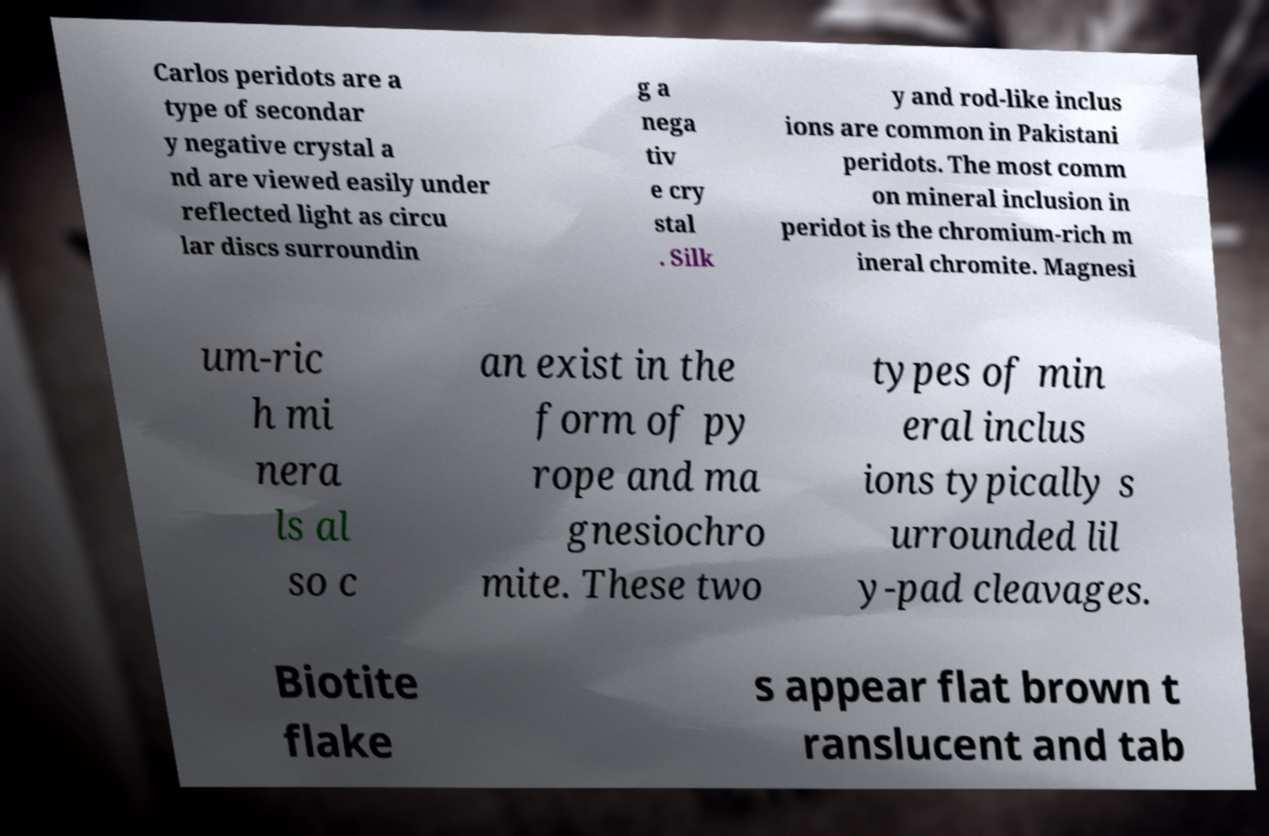Please identify and transcribe the text found in this image. Carlos peridots are a type of secondar y negative crystal a nd are viewed easily under reflected light as circu lar discs surroundin g a nega tiv e cry stal . Silk y and rod-like inclus ions are common in Pakistani peridots. The most comm on mineral inclusion in peridot is the chromium-rich m ineral chromite. Magnesi um-ric h mi nera ls al so c an exist in the form of py rope and ma gnesiochro mite. These two types of min eral inclus ions typically s urrounded lil y-pad cleavages. Biotite flake s appear flat brown t ranslucent and tab 